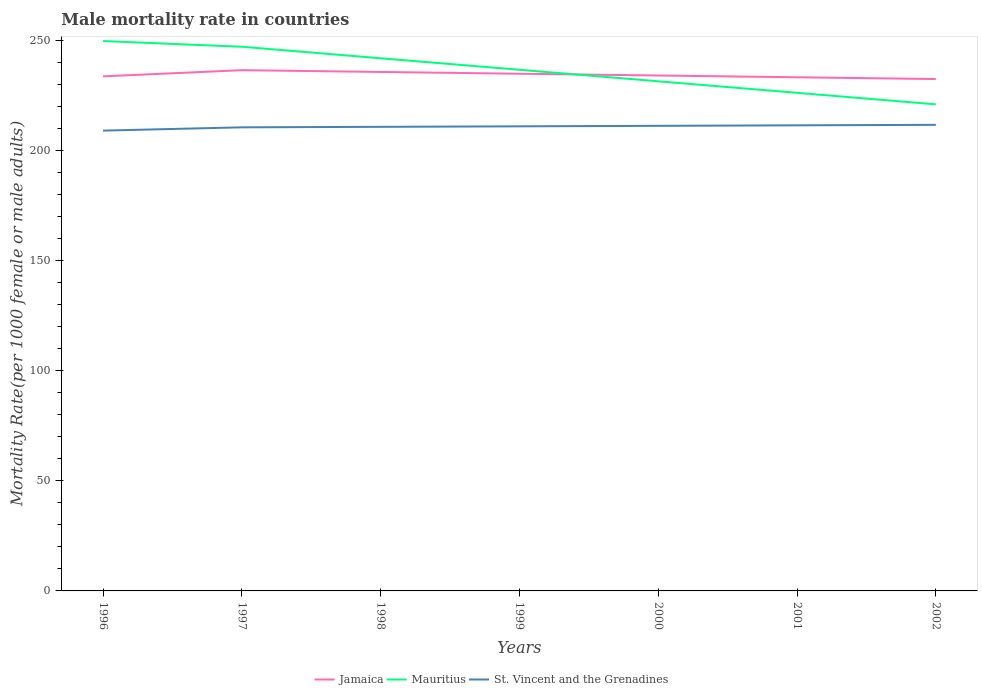How many different coloured lines are there?
Make the answer very short. 3. Is the number of lines equal to the number of legend labels?
Ensure brevity in your answer.  Yes. Across all years, what is the maximum male mortality rate in Jamaica?
Provide a short and direct response. 232.63. In which year was the male mortality rate in Jamaica maximum?
Give a very brief answer. 2002. What is the total male mortality rate in St. Vincent and the Grenadines in the graph?
Give a very brief answer. -1.72. What is the difference between the highest and the second highest male mortality rate in Jamaica?
Your answer should be very brief. 4.03. Is the male mortality rate in St. Vincent and the Grenadines strictly greater than the male mortality rate in Jamaica over the years?
Your answer should be compact. Yes. How many lines are there?
Offer a terse response. 3. How many years are there in the graph?
Give a very brief answer. 7. What is the title of the graph?
Make the answer very short. Male mortality rate in countries. Does "Central African Republic" appear as one of the legend labels in the graph?
Make the answer very short. No. What is the label or title of the X-axis?
Ensure brevity in your answer.  Years. What is the label or title of the Y-axis?
Your answer should be very brief. Mortality Rate(per 1000 female or male adults). What is the Mortality Rate(per 1000 female or male adults) in Jamaica in 1996?
Your answer should be compact. 233.86. What is the Mortality Rate(per 1000 female or male adults) in Mauritius in 1996?
Offer a very short reply. 249.9. What is the Mortality Rate(per 1000 female or male adults) of St. Vincent and the Grenadines in 1996?
Your answer should be compact. 209.2. What is the Mortality Rate(per 1000 female or male adults) of Jamaica in 1997?
Your response must be concise. 236.67. What is the Mortality Rate(per 1000 female or male adults) in Mauritius in 1997?
Your answer should be compact. 247.32. What is the Mortality Rate(per 1000 female or male adults) of St. Vincent and the Grenadines in 1997?
Ensure brevity in your answer.  210.69. What is the Mortality Rate(per 1000 female or male adults) of Jamaica in 1998?
Offer a very short reply. 235.86. What is the Mortality Rate(per 1000 female or male adults) of Mauritius in 1998?
Your response must be concise. 242.08. What is the Mortality Rate(per 1000 female or male adults) in St. Vincent and the Grenadines in 1998?
Offer a very short reply. 210.92. What is the Mortality Rate(per 1000 female or male adults) of Jamaica in 1999?
Provide a succinct answer. 235.05. What is the Mortality Rate(per 1000 female or male adults) of Mauritius in 1999?
Your answer should be very brief. 236.85. What is the Mortality Rate(per 1000 female or male adults) in St. Vincent and the Grenadines in 1999?
Provide a succinct answer. 211.15. What is the Mortality Rate(per 1000 female or male adults) of Jamaica in 2000?
Your response must be concise. 234.25. What is the Mortality Rate(per 1000 female or male adults) in Mauritius in 2000?
Provide a short and direct response. 231.61. What is the Mortality Rate(per 1000 female or male adults) in St. Vincent and the Grenadines in 2000?
Offer a terse response. 211.38. What is the Mortality Rate(per 1000 female or male adults) of Jamaica in 2001?
Offer a terse response. 233.44. What is the Mortality Rate(per 1000 female or male adults) of Mauritius in 2001?
Make the answer very short. 226.38. What is the Mortality Rate(per 1000 female or male adults) of St. Vincent and the Grenadines in 2001?
Give a very brief answer. 211.6. What is the Mortality Rate(per 1000 female or male adults) in Jamaica in 2002?
Give a very brief answer. 232.63. What is the Mortality Rate(per 1000 female or male adults) in Mauritius in 2002?
Provide a succinct answer. 221.14. What is the Mortality Rate(per 1000 female or male adults) in St. Vincent and the Grenadines in 2002?
Give a very brief answer. 211.83. Across all years, what is the maximum Mortality Rate(per 1000 female or male adults) in Jamaica?
Ensure brevity in your answer.  236.67. Across all years, what is the maximum Mortality Rate(per 1000 female or male adults) of Mauritius?
Keep it short and to the point. 249.9. Across all years, what is the maximum Mortality Rate(per 1000 female or male adults) in St. Vincent and the Grenadines?
Your answer should be compact. 211.83. Across all years, what is the minimum Mortality Rate(per 1000 female or male adults) of Jamaica?
Your answer should be compact. 232.63. Across all years, what is the minimum Mortality Rate(per 1000 female or male adults) of Mauritius?
Keep it short and to the point. 221.14. Across all years, what is the minimum Mortality Rate(per 1000 female or male adults) in St. Vincent and the Grenadines?
Offer a terse response. 209.2. What is the total Mortality Rate(per 1000 female or male adults) in Jamaica in the graph?
Provide a short and direct response. 1641.76. What is the total Mortality Rate(per 1000 female or male adults) in Mauritius in the graph?
Your response must be concise. 1655.28. What is the total Mortality Rate(per 1000 female or male adults) in St. Vincent and the Grenadines in the graph?
Keep it short and to the point. 1476.77. What is the difference between the Mortality Rate(per 1000 female or male adults) of Jamaica in 1996 and that in 1997?
Your response must be concise. -2.81. What is the difference between the Mortality Rate(per 1000 female or male adults) of Mauritius in 1996 and that in 1997?
Keep it short and to the point. 2.59. What is the difference between the Mortality Rate(per 1000 female or male adults) in St. Vincent and the Grenadines in 1996 and that in 1997?
Provide a succinct answer. -1.5. What is the difference between the Mortality Rate(per 1000 female or male adults) of Jamaica in 1996 and that in 1998?
Your response must be concise. -2. What is the difference between the Mortality Rate(per 1000 female or male adults) of Mauritius in 1996 and that in 1998?
Provide a succinct answer. 7.82. What is the difference between the Mortality Rate(per 1000 female or male adults) in St. Vincent and the Grenadines in 1996 and that in 1998?
Provide a succinct answer. -1.72. What is the difference between the Mortality Rate(per 1000 female or male adults) of Jamaica in 1996 and that in 1999?
Provide a short and direct response. -1.2. What is the difference between the Mortality Rate(per 1000 female or male adults) of Mauritius in 1996 and that in 1999?
Your response must be concise. 13.06. What is the difference between the Mortality Rate(per 1000 female or male adults) of St. Vincent and the Grenadines in 1996 and that in 1999?
Your answer should be very brief. -1.95. What is the difference between the Mortality Rate(per 1000 female or male adults) in Jamaica in 1996 and that in 2000?
Offer a very short reply. -0.39. What is the difference between the Mortality Rate(per 1000 female or male adults) of Mauritius in 1996 and that in 2000?
Provide a short and direct response. 18.29. What is the difference between the Mortality Rate(per 1000 female or male adults) of St. Vincent and the Grenadines in 1996 and that in 2000?
Offer a very short reply. -2.18. What is the difference between the Mortality Rate(per 1000 female or male adults) in Jamaica in 1996 and that in 2001?
Your answer should be compact. 0.42. What is the difference between the Mortality Rate(per 1000 female or male adults) in Mauritius in 1996 and that in 2001?
Keep it short and to the point. 23.53. What is the difference between the Mortality Rate(per 1000 female or male adults) in St. Vincent and the Grenadines in 1996 and that in 2001?
Your answer should be very brief. -2.4. What is the difference between the Mortality Rate(per 1000 female or male adults) in Jamaica in 1996 and that in 2002?
Ensure brevity in your answer.  1.23. What is the difference between the Mortality Rate(per 1000 female or male adults) in Mauritius in 1996 and that in 2002?
Keep it short and to the point. 28.76. What is the difference between the Mortality Rate(per 1000 female or male adults) in St. Vincent and the Grenadines in 1996 and that in 2002?
Keep it short and to the point. -2.63. What is the difference between the Mortality Rate(per 1000 female or male adults) of Jamaica in 1997 and that in 1998?
Your answer should be very brief. 0.81. What is the difference between the Mortality Rate(per 1000 female or male adults) in Mauritius in 1997 and that in 1998?
Your answer should be very brief. 5.24. What is the difference between the Mortality Rate(per 1000 female or male adults) of St. Vincent and the Grenadines in 1997 and that in 1998?
Ensure brevity in your answer.  -0.23. What is the difference between the Mortality Rate(per 1000 female or male adults) of Jamaica in 1997 and that in 1999?
Offer a terse response. 1.61. What is the difference between the Mortality Rate(per 1000 female or male adults) in Mauritius in 1997 and that in 1999?
Your answer should be compact. 10.47. What is the difference between the Mortality Rate(per 1000 female or male adults) in St. Vincent and the Grenadines in 1997 and that in 1999?
Keep it short and to the point. -0.45. What is the difference between the Mortality Rate(per 1000 female or male adults) of Jamaica in 1997 and that in 2000?
Offer a very short reply. 2.42. What is the difference between the Mortality Rate(per 1000 female or male adults) in Mauritius in 1997 and that in 2000?
Ensure brevity in your answer.  15.71. What is the difference between the Mortality Rate(per 1000 female or male adults) of St. Vincent and the Grenadines in 1997 and that in 2000?
Offer a very short reply. -0.68. What is the difference between the Mortality Rate(per 1000 female or male adults) in Jamaica in 1997 and that in 2001?
Keep it short and to the point. 3.23. What is the difference between the Mortality Rate(per 1000 female or male adults) in Mauritius in 1997 and that in 2001?
Give a very brief answer. 20.94. What is the difference between the Mortality Rate(per 1000 female or male adults) in St. Vincent and the Grenadines in 1997 and that in 2001?
Your response must be concise. -0.91. What is the difference between the Mortality Rate(per 1000 female or male adults) in Jamaica in 1997 and that in 2002?
Offer a very short reply. 4.03. What is the difference between the Mortality Rate(per 1000 female or male adults) in Mauritius in 1997 and that in 2002?
Offer a very short reply. 26.18. What is the difference between the Mortality Rate(per 1000 female or male adults) of St. Vincent and the Grenadines in 1997 and that in 2002?
Provide a succinct answer. -1.14. What is the difference between the Mortality Rate(per 1000 female or male adults) of Jamaica in 1998 and that in 1999?
Offer a terse response. 0.81. What is the difference between the Mortality Rate(per 1000 female or male adults) of Mauritius in 1998 and that in 1999?
Give a very brief answer. 5.24. What is the difference between the Mortality Rate(per 1000 female or male adults) in St. Vincent and the Grenadines in 1998 and that in 1999?
Provide a succinct answer. -0.23. What is the difference between the Mortality Rate(per 1000 female or male adults) in Jamaica in 1998 and that in 2000?
Offer a very short reply. 1.61. What is the difference between the Mortality Rate(per 1000 female or male adults) of Mauritius in 1998 and that in 2000?
Your response must be concise. 10.47. What is the difference between the Mortality Rate(per 1000 female or male adults) in St. Vincent and the Grenadines in 1998 and that in 2000?
Make the answer very short. -0.45. What is the difference between the Mortality Rate(per 1000 female or male adults) in Jamaica in 1998 and that in 2001?
Make the answer very short. 2.42. What is the difference between the Mortality Rate(per 1000 female or male adults) of Mauritius in 1998 and that in 2001?
Provide a succinct answer. 15.71. What is the difference between the Mortality Rate(per 1000 female or male adults) of St. Vincent and the Grenadines in 1998 and that in 2001?
Ensure brevity in your answer.  -0.68. What is the difference between the Mortality Rate(per 1000 female or male adults) of Jamaica in 1998 and that in 2002?
Your answer should be compact. 3.23. What is the difference between the Mortality Rate(per 1000 female or male adults) of Mauritius in 1998 and that in 2002?
Give a very brief answer. 20.94. What is the difference between the Mortality Rate(per 1000 female or male adults) in St. Vincent and the Grenadines in 1998 and that in 2002?
Keep it short and to the point. -0.91. What is the difference between the Mortality Rate(per 1000 female or male adults) in Jamaica in 1999 and that in 2000?
Your answer should be compact. 0.81. What is the difference between the Mortality Rate(per 1000 female or male adults) of Mauritius in 1999 and that in 2000?
Your response must be concise. 5.24. What is the difference between the Mortality Rate(per 1000 female or male adults) of St. Vincent and the Grenadines in 1999 and that in 2000?
Provide a succinct answer. -0.23. What is the difference between the Mortality Rate(per 1000 female or male adults) in Jamaica in 1999 and that in 2001?
Provide a succinct answer. 1.61. What is the difference between the Mortality Rate(per 1000 female or male adults) of Mauritius in 1999 and that in 2001?
Your response must be concise. 10.47. What is the difference between the Mortality Rate(per 1000 female or male adults) of St. Vincent and the Grenadines in 1999 and that in 2001?
Provide a succinct answer. -0.45. What is the difference between the Mortality Rate(per 1000 female or male adults) of Jamaica in 1999 and that in 2002?
Provide a short and direct response. 2.42. What is the difference between the Mortality Rate(per 1000 female or male adults) of Mauritius in 1999 and that in 2002?
Keep it short and to the point. 15.71. What is the difference between the Mortality Rate(per 1000 female or male adults) of St. Vincent and the Grenadines in 1999 and that in 2002?
Offer a terse response. -0.68. What is the difference between the Mortality Rate(per 1000 female or male adults) of Jamaica in 2000 and that in 2001?
Provide a short and direct response. 0.81. What is the difference between the Mortality Rate(per 1000 female or male adults) in Mauritius in 2000 and that in 2001?
Offer a terse response. 5.24. What is the difference between the Mortality Rate(per 1000 female or male adults) in St. Vincent and the Grenadines in 2000 and that in 2001?
Your response must be concise. -0.23. What is the difference between the Mortality Rate(per 1000 female or male adults) of Jamaica in 2000 and that in 2002?
Your response must be concise. 1.61. What is the difference between the Mortality Rate(per 1000 female or male adults) of Mauritius in 2000 and that in 2002?
Your answer should be very brief. 10.47. What is the difference between the Mortality Rate(per 1000 female or male adults) of St. Vincent and the Grenadines in 2000 and that in 2002?
Ensure brevity in your answer.  -0.45. What is the difference between the Mortality Rate(per 1000 female or male adults) of Jamaica in 2001 and that in 2002?
Provide a succinct answer. 0.81. What is the difference between the Mortality Rate(per 1000 female or male adults) in Mauritius in 2001 and that in 2002?
Your answer should be compact. 5.24. What is the difference between the Mortality Rate(per 1000 female or male adults) of St. Vincent and the Grenadines in 2001 and that in 2002?
Your answer should be very brief. -0.23. What is the difference between the Mortality Rate(per 1000 female or male adults) in Jamaica in 1996 and the Mortality Rate(per 1000 female or male adults) in Mauritius in 1997?
Provide a succinct answer. -13.46. What is the difference between the Mortality Rate(per 1000 female or male adults) in Jamaica in 1996 and the Mortality Rate(per 1000 female or male adults) in St. Vincent and the Grenadines in 1997?
Offer a very short reply. 23.16. What is the difference between the Mortality Rate(per 1000 female or male adults) of Mauritius in 1996 and the Mortality Rate(per 1000 female or male adults) of St. Vincent and the Grenadines in 1997?
Offer a terse response. 39.21. What is the difference between the Mortality Rate(per 1000 female or male adults) of Jamaica in 1996 and the Mortality Rate(per 1000 female or male adults) of Mauritius in 1998?
Provide a succinct answer. -8.22. What is the difference between the Mortality Rate(per 1000 female or male adults) in Jamaica in 1996 and the Mortality Rate(per 1000 female or male adults) in St. Vincent and the Grenadines in 1998?
Offer a terse response. 22.94. What is the difference between the Mortality Rate(per 1000 female or male adults) in Mauritius in 1996 and the Mortality Rate(per 1000 female or male adults) in St. Vincent and the Grenadines in 1998?
Make the answer very short. 38.98. What is the difference between the Mortality Rate(per 1000 female or male adults) of Jamaica in 1996 and the Mortality Rate(per 1000 female or male adults) of Mauritius in 1999?
Your answer should be compact. -2.99. What is the difference between the Mortality Rate(per 1000 female or male adults) of Jamaica in 1996 and the Mortality Rate(per 1000 female or male adults) of St. Vincent and the Grenadines in 1999?
Ensure brevity in your answer.  22.71. What is the difference between the Mortality Rate(per 1000 female or male adults) in Mauritius in 1996 and the Mortality Rate(per 1000 female or male adults) in St. Vincent and the Grenadines in 1999?
Keep it short and to the point. 38.76. What is the difference between the Mortality Rate(per 1000 female or male adults) in Jamaica in 1996 and the Mortality Rate(per 1000 female or male adults) in Mauritius in 2000?
Provide a short and direct response. 2.25. What is the difference between the Mortality Rate(per 1000 female or male adults) in Jamaica in 1996 and the Mortality Rate(per 1000 female or male adults) in St. Vincent and the Grenadines in 2000?
Your answer should be compact. 22.48. What is the difference between the Mortality Rate(per 1000 female or male adults) in Mauritius in 1996 and the Mortality Rate(per 1000 female or male adults) in St. Vincent and the Grenadines in 2000?
Your answer should be compact. 38.53. What is the difference between the Mortality Rate(per 1000 female or male adults) of Jamaica in 1996 and the Mortality Rate(per 1000 female or male adults) of Mauritius in 2001?
Offer a terse response. 7.48. What is the difference between the Mortality Rate(per 1000 female or male adults) in Jamaica in 1996 and the Mortality Rate(per 1000 female or male adults) in St. Vincent and the Grenadines in 2001?
Offer a terse response. 22.26. What is the difference between the Mortality Rate(per 1000 female or male adults) of Mauritius in 1996 and the Mortality Rate(per 1000 female or male adults) of St. Vincent and the Grenadines in 2001?
Keep it short and to the point. 38.3. What is the difference between the Mortality Rate(per 1000 female or male adults) in Jamaica in 1996 and the Mortality Rate(per 1000 female or male adults) in Mauritius in 2002?
Give a very brief answer. 12.72. What is the difference between the Mortality Rate(per 1000 female or male adults) in Jamaica in 1996 and the Mortality Rate(per 1000 female or male adults) in St. Vincent and the Grenadines in 2002?
Make the answer very short. 22.03. What is the difference between the Mortality Rate(per 1000 female or male adults) in Mauritius in 1996 and the Mortality Rate(per 1000 female or male adults) in St. Vincent and the Grenadines in 2002?
Your answer should be compact. 38.07. What is the difference between the Mortality Rate(per 1000 female or male adults) of Jamaica in 1997 and the Mortality Rate(per 1000 female or male adults) of Mauritius in 1998?
Offer a terse response. -5.41. What is the difference between the Mortality Rate(per 1000 female or male adults) in Jamaica in 1997 and the Mortality Rate(per 1000 female or male adults) in St. Vincent and the Grenadines in 1998?
Offer a terse response. 25.75. What is the difference between the Mortality Rate(per 1000 female or male adults) in Mauritius in 1997 and the Mortality Rate(per 1000 female or male adults) in St. Vincent and the Grenadines in 1998?
Offer a terse response. 36.4. What is the difference between the Mortality Rate(per 1000 female or male adults) of Jamaica in 1997 and the Mortality Rate(per 1000 female or male adults) of Mauritius in 1999?
Give a very brief answer. -0.18. What is the difference between the Mortality Rate(per 1000 female or male adults) of Jamaica in 1997 and the Mortality Rate(per 1000 female or male adults) of St. Vincent and the Grenadines in 1999?
Make the answer very short. 25.52. What is the difference between the Mortality Rate(per 1000 female or male adults) in Mauritius in 1997 and the Mortality Rate(per 1000 female or male adults) in St. Vincent and the Grenadines in 1999?
Your response must be concise. 36.17. What is the difference between the Mortality Rate(per 1000 female or male adults) in Jamaica in 1997 and the Mortality Rate(per 1000 female or male adults) in Mauritius in 2000?
Your answer should be very brief. 5.06. What is the difference between the Mortality Rate(per 1000 female or male adults) in Jamaica in 1997 and the Mortality Rate(per 1000 female or male adults) in St. Vincent and the Grenadines in 2000?
Your answer should be very brief. 25.29. What is the difference between the Mortality Rate(per 1000 female or male adults) in Mauritius in 1997 and the Mortality Rate(per 1000 female or male adults) in St. Vincent and the Grenadines in 2000?
Keep it short and to the point. 35.94. What is the difference between the Mortality Rate(per 1000 female or male adults) of Jamaica in 1997 and the Mortality Rate(per 1000 female or male adults) of Mauritius in 2001?
Offer a very short reply. 10.29. What is the difference between the Mortality Rate(per 1000 female or male adults) of Jamaica in 1997 and the Mortality Rate(per 1000 female or male adults) of St. Vincent and the Grenadines in 2001?
Make the answer very short. 25.07. What is the difference between the Mortality Rate(per 1000 female or male adults) of Mauritius in 1997 and the Mortality Rate(per 1000 female or male adults) of St. Vincent and the Grenadines in 2001?
Offer a terse response. 35.72. What is the difference between the Mortality Rate(per 1000 female or male adults) of Jamaica in 1997 and the Mortality Rate(per 1000 female or male adults) of Mauritius in 2002?
Provide a short and direct response. 15.53. What is the difference between the Mortality Rate(per 1000 female or male adults) in Jamaica in 1997 and the Mortality Rate(per 1000 female or male adults) in St. Vincent and the Grenadines in 2002?
Your answer should be very brief. 24.84. What is the difference between the Mortality Rate(per 1000 female or male adults) in Mauritius in 1997 and the Mortality Rate(per 1000 female or male adults) in St. Vincent and the Grenadines in 2002?
Give a very brief answer. 35.49. What is the difference between the Mortality Rate(per 1000 female or male adults) of Jamaica in 1998 and the Mortality Rate(per 1000 female or male adults) of Mauritius in 1999?
Your response must be concise. -0.99. What is the difference between the Mortality Rate(per 1000 female or male adults) of Jamaica in 1998 and the Mortality Rate(per 1000 female or male adults) of St. Vincent and the Grenadines in 1999?
Offer a very short reply. 24.71. What is the difference between the Mortality Rate(per 1000 female or male adults) of Mauritius in 1998 and the Mortality Rate(per 1000 female or male adults) of St. Vincent and the Grenadines in 1999?
Your answer should be compact. 30.93. What is the difference between the Mortality Rate(per 1000 female or male adults) in Jamaica in 1998 and the Mortality Rate(per 1000 female or male adults) in Mauritius in 2000?
Make the answer very short. 4.25. What is the difference between the Mortality Rate(per 1000 female or male adults) in Jamaica in 1998 and the Mortality Rate(per 1000 female or male adults) in St. Vincent and the Grenadines in 2000?
Ensure brevity in your answer.  24.49. What is the difference between the Mortality Rate(per 1000 female or male adults) of Mauritius in 1998 and the Mortality Rate(per 1000 female or male adults) of St. Vincent and the Grenadines in 2000?
Your answer should be compact. 30.71. What is the difference between the Mortality Rate(per 1000 female or male adults) in Jamaica in 1998 and the Mortality Rate(per 1000 female or male adults) in Mauritius in 2001?
Make the answer very short. 9.48. What is the difference between the Mortality Rate(per 1000 female or male adults) of Jamaica in 1998 and the Mortality Rate(per 1000 female or male adults) of St. Vincent and the Grenadines in 2001?
Offer a very short reply. 24.26. What is the difference between the Mortality Rate(per 1000 female or male adults) in Mauritius in 1998 and the Mortality Rate(per 1000 female or male adults) in St. Vincent and the Grenadines in 2001?
Offer a very short reply. 30.48. What is the difference between the Mortality Rate(per 1000 female or male adults) of Jamaica in 1998 and the Mortality Rate(per 1000 female or male adults) of Mauritius in 2002?
Your answer should be compact. 14.72. What is the difference between the Mortality Rate(per 1000 female or male adults) in Jamaica in 1998 and the Mortality Rate(per 1000 female or male adults) in St. Vincent and the Grenadines in 2002?
Provide a succinct answer. 24.03. What is the difference between the Mortality Rate(per 1000 female or male adults) of Mauritius in 1998 and the Mortality Rate(per 1000 female or male adults) of St. Vincent and the Grenadines in 2002?
Your answer should be very brief. 30.25. What is the difference between the Mortality Rate(per 1000 female or male adults) in Jamaica in 1999 and the Mortality Rate(per 1000 female or male adults) in Mauritius in 2000?
Give a very brief answer. 3.44. What is the difference between the Mortality Rate(per 1000 female or male adults) in Jamaica in 1999 and the Mortality Rate(per 1000 female or male adults) in St. Vincent and the Grenadines in 2000?
Provide a succinct answer. 23.68. What is the difference between the Mortality Rate(per 1000 female or male adults) in Mauritius in 1999 and the Mortality Rate(per 1000 female or male adults) in St. Vincent and the Grenadines in 2000?
Provide a short and direct response. 25.47. What is the difference between the Mortality Rate(per 1000 female or male adults) in Jamaica in 1999 and the Mortality Rate(per 1000 female or male adults) in Mauritius in 2001?
Keep it short and to the point. 8.68. What is the difference between the Mortality Rate(per 1000 female or male adults) in Jamaica in 1999 and the Mortality Rate(per 1000 female or male adults) in St. Vincent and the Grenadines in 2001?
Your answer should be very brief. 23.45. What is the difference between the Mortality Rate(per 1000 female or male adults) in Mauritius in 1999 and the Mortality Rate(per 1000 female or male adults) in St. Vincent and the Grenadines in 2001?
Provide a short and direct response. 25.24. What is the difference between the Mortality Rate(per 1000 female or male adults) of Jamaica in 1999 and the Mortality Rate(per 1000 female or male adults) of Mauritius in 2002?
Keep it short and to the point. 13.91. What is the difference between the Mortality Rate(per 1000 female or male adults) of Jamaica in 1999 and the Mortality Rate(per 1000 female or male adults) of St. Vincent and the Grenadines in 2002?
Offer a terse response. 23.22. What is the difference between the Mortality Rate(per 1000 female or male adults) in Mauritius in 1999 and the Mortality Rate(per 1000 female or male adults) in St. Vincent and the Grenadines in 2002?
Your answer should be compact. 25.02. What is the difference between the Mortality Rate(per 1000 female or male adults) of Jamaica in 2000 and the Mortality Rate(per 1000 female or male adults) of Mauritius in 2001?
Give a very brief answer. 7.87. What is the difference between the Mortality Rate(per 1000 female or male adults) of Jamaica in 2000 and the Mortality Rate(per 1000 female or male adults) of St. Vincent and the Grenadines in 2001?
Offer a very short reply. 22.64. What is the difference between the Mortality Rate(per 1000 female or male adults) in Mauritius in 2000 and the Mortality Rate(per 1000 female or male adults) in St. Vincent and the Grenadines in 2001?
Your answer should be very brief. 20.01. What is the difference between the Mortality Rate(per 1000 female or male adults) in Jamaica in 2000 and the Mortality Rate(per 1000 female or male adults) in Mauritius in 2002?
Keep it short and to the point. 13.11. What is the difference between the Mortality Rate(per 1000 female or male adults) of Jamaica in 2000 and the Mortality Rate(per 1000 female or male adults) of St. Vincent and the Grenadines in 2002?
Offer a very short reply. 22.42. What is the difference between the Mortality Rate(per 1000 female or male adults) in Mauritius in 2000 and the Mortality Rate(per 1000 female or male adults) in St. Vincent and the Grenadines in 2002?
Provide a succinct answer. 19.78. What is the difference between the Mortality Rate(per 1000 female or male adults) of Jamaica in 2001 and the Mortality Rate(per 1000 female or male adults) of Mauritius in 2002?
Offer a terse response. 12.3. What is the difference between the Mortality Rate(per 1000 female or male adults) of Jamaica in 2001 and the Mortality Rate(per 1000 female or male adults) of St. Vincent and the Grenadines in 2002?
Your answer should be compact. 21.61. What is the difference between the Mortality Rate(per 1000 female or male adults) in Mauritius in 2001 and the Mortality Rate(per 1000 female or male adults) in St. Vincent and the Grenadines in 2002?
Your answer should be very brief. 14.55. What is the average Mortality Rate(per 1000 female or male adults) of Jamaica per year?
Ensure brevity in your answer.  234.54. What is the average Mortality Rate(per 1000 female or male adults) of Mauritius per year?
Give a very brief answer. 236.47. What is the average Mortality Rate(per 1000 female or male adults) in St. Vincent and the Grenadines per year?
Make the answer very short. 210.97. In the year 1996, what is the difference between the Mortality Rate(per 1000 female or male adults) in Jamaica and Mortality Rate(per 1000 female or male adults) in Mauritius?
Offer a terse response. -16.05. In the year 1996, what is the difference between the Mortality Rate(per 1000 female or male adults) of Jamaica and Mortality Rate(per 1000 female or male adults) of St. Vincent and the Grenadines?
Provide a short and direct response. 24.66. In the year 1996, what is the difference between the Mortality Rate(per 1000 female or male adults) in Mauritius and Mortality Rate(per 1000 female or male adults) in St. Vincent and the Grenadines?
Provide a short and direct response. 40.7. In the year 1997, what is the difference between the Mortality Rate(per 1000 female or male adults) of Jamaica and Mortality Rate(per 1000 female or male adults) of Mauritius?
Offer a terse response. -10.65. In the year 1997, what is the difference between the Mortality Rate(per 1000 female or male adults) of Jamaica and Mortality Rate(per 1000 female or male adults) of St. Vincent and the Grenadines?
Provide a succinct answer. 25.97. In the year 1997, what is the difference between the Mortality Rate(per 1000 female or male adults) of Mauritius and Mortality Rate(per 1000 female or male adults) of St. Vincent and the Grenadines?
Your response must be concise. 36.62. In the year 1998, what is the difference between the Mortality Rate(per 1000 female or male adults) in Jamaica and Mortality Rate(per 1000 female or male adults) in Mauritius?
Make the answer very short. -6.22. In the year 1998, what is the difference between the Mortality Rate(per 1000 female or male adults) in Jamaica and Mortality Rate(per 1000 female or male adults) in St. Vincent and the Grenadines?
Your response must be concise. 24.94. In the year 1998, what is the difference between the Mortality Rate(per 1000 female or male adults) of Mauritius and Mortality Rate(per 1000 female or male adults) of St. Vincent and the Grenadines?
Make the answer very short. 31.16. In the year 1999, what is the difference between the Mortality Rate(per 1000 female or male adults) of Jamaica and Mortality Rate(per 1000 female or male adults) of Mauritius?
Your response must be concise. -1.79. In the year 1999, what is the difference between the Mortality Rate(per 1000 female or male adults) in Jamaica and Mortality Rate(per 1000 female or male adults) in St. Vincent and the Grenadines?
Your answer should be compact. 23.91. In the year 1999, what is the difference between the Mortality Rate(per 1000 female or male adults) in Mauritius and Mortality Rate(per 1000 female or male adults) in St. Vincent and the Grenadines?
Offer a terse response. 25.7. In the year 2000, what is the difference between the Mortality Rate(per 1000 female or male adults) in Jamaica and Mortality Rate(per 1000 female or male adults) in Mauritius?
Your response must be concise. 2.64. In the year 2000, what is the difference between the Mortality Rate(per 1000 female or male adults) in Jamaica and Mortality Rate(per 1000 female or male adults) in St. Vincent and the Grenadines?
Keep it short and to the point. 22.87. In the year 2000, what is the difference between the Mortality Rate(per 1000 female or male adults) of Mauritius and Mortality Rate(per 1000 female or male adults) of St. Vincent and the Grenadines?
Make the answer very short. 20.24. In the year 2001, what is the difference between the Mortality Rate(per 1000 female or male adults) in Jamaica and Mortality Rate(per 1000 female or male adults) in Mauritius?
Offer a terse response. 7.06. In the year 2001, what is the difference between the Mortality Rate(per 1000 female or male adults) in Jamaica and Mortality Rate(per 1000 female or male adults) in St. Vincent and the Grenadines?
Keep it short and to the point. 21.84. In the year 2001, what is the difference between the Mortality Rate(per 1000 female or male adults) of Mauritius and Mortality Rate(per 1000 female or male adults) of St. Vincent and the Grenadines?
Make the answer very short. 14.77. In the year 2002, what is the difference between the Mortality Rate(per 1000 female or male adults) of Jamaica and Mortality Rate(per 1000 female or male adults) of Mauritius?
Offer a terse response. 11.49. In the year 2002, what is the difference between the Mortality Rate(per 1000 female or male adults) in Jamaica and Mortality Rate(per 1000 female or male adults) in St. Vincent and the Grenadines?
Your answer should be compact. 20.8. In the year 2002, what is the difference between the Mortality Rate(per 1000 female or male adults) in Mauritius and Mortality Rate(per 1000 female or male adults) in St. Vincent and the Grenadines?
Provide a short and direct response. 9.31. What is the ratio of the Mortality Rate(per 1000 female or male adults) of Jamaica in 1996 to that in 1997?
Keep it short and to the point. 0.99. What is the ratio of the Mortality Rate(per 1000 female or male adults) of Mauritius in 1996 to that in 1997?
Offer a very short reply. 1.01. What is the ratio of the Mortality Rate(per 1000 female or male adults) in St. Vincent and the Grenadines in 1996 to that in 1997?
Keep it short and to the point. 0.99. What is the ratio of the Mortality Rate(per 1000 female or male adults) of Jamaica in 1996 to that in 1998?
Make the answer very short. 0.99. What is the ratio of the Mortality Rate(per 1000 female or male adults) in Mauritius in 1996 to that in 1998?
Keep it short and to the point. 1.03. What is the ratio of the Mortality Rate(per 1000 female or male adults) in St. Vincent and the Grenadines in 1996 to that in 1998?
Make the answer very short. 0.99. What is the ratio of the Mortality Rate(per 1000 female or male adults) in Jamaica in 1996 to that in 1999?
Give a very brief answer. 0.99. What is the ratio of the Mortality Rate(per 1000 female or male adults) in Mauritius in 1996 to that in 1999?
Provide a succinct answer. 1.06. What is the ratio of the Mortality Rate(per 1000 female or male adults) of Jamaica in 1996 to that in 2000?
Provide a short and direct response. 1. What is the ratio of the Mortality Rate(per 1000 female or male adults) of Mauritius in 1996 to that in 2000?
Your answer should be compact. 1.08. What is the ratio of the Mortality Rate(per 1000 female or male adults) of Mauritius in 1996 to that in 2001?
Give a very brief answer. 1.1. What is the ratio of the Mortality Rate(per 1000 female or male adults) of St. Vincent and the Grenadines in 1996 to that in 2001?
Your answer should be compact. 0.99. What is the ratio of the Mortality Rate(per 1000 female or male adults) of Jamaica in 1996 to that in 2002?
Keep it short and to the point. 1.01. What is the ratio of the Mortality Rate(per 1000 female or male adults) of Mauritius in 1996 to that in 2002?
Ensure brevity in your answer.  1.13. What is the ratio of the Mortality Rate(per 1000 female or male adults) in St. Vincent and the Grenadines in 1996 to that in 2002?
Your answer should be compact. 0.99. What is the ratio of the Mortality Rate(per 1000 female or male adults) in Jamaica in 1997 to that in 1998?
Provide a short and direct response. 1. What is the ratio of the Mortality Rate(per 1000 female or male adults) of Mauritius in 1997 to that in 1998?
Offer a very short reply. 1.02. What is the ratio of the Mortality Rate(per 1000 female or male adults) of St. Vincent and the Grenadines in 1997 to that in 1998?
Ensure brevity in your answer.  1. What is the ratio of the Mortality Rate(per 1000 female or male adults) of Mauritius in 1997 to that in 1999?
Make the answer very short. 1.04. What is the ratio of the Mortality Rate(per 1000 female or male adults) of St. Vincent and the Grenadines in 1997 to that in 1999?
Offer a terse response. 1. What is the ratio of the Mortality Rate(per 1000 female or male adults) in Jamaica in 1997 to that in 2000?
Your response must be concise. 1.01. What is the ratio of the Mortality Rate(per 1000 female or male adults) of Mauritius in 1997 to that in 2000?
Provide a succinct answer. 1.07. What is the ratio of the Mortality Rate(per 1000 female or male adults) in Jamaica in 1997 to that in 2001?
Offer a very short reply. 1.01. What is the ratio of the Mortality Rate(per 1000 female or male adults) of Mauritius in 1997 to that in 2001?
Your answer should be very brief. 1.09. What is the ratio of the Mortality Rate(per 1000 female or male adults) in Jamaica in 1997 to that in 2002?
Your answer should be compact. 1.02. What is the ratio of the Mortality Rate(per 1000 female or male adults) of Mauritius in 1997 to that in 2002?
Provide a succinct answer. 1.12. What is the ratio of the Mortality Rate(per 1000 female or male adults) in St. Vincent and the Grenadines in 1997 to that in 2002?
Keep it short and to the point. 0.99. What is the ratio of the Mortality Rate(per 1000 female or male adults) of Jamaica in 1998 to that in 1999?
Make the answer very short. 1. What is the ratio of the Mortality Rate(per 1000 female or male adults) in Mauritius in 1998 to that in 1999?
Ensure brevity in your answer.  1.02. What is the ratio of the Mortality Rate(per 1000 female or male adults) of Jamaica in 1998 to that in 2000?
Your answer should be very brief. 1.01. What is the ratio of the Mortality Rate(per 1000 female or male adults) of Mauritius in 1998 to that in 2000?
Keep it short and to the point. 1.05. What is the ratio of the Mortality Rate(per 1000 female or male adults) of Jamaica in 1998 to that in 2001?
Keep it short and to the point. 1.01. What is the ratio of the Mortality Rate(per 1000 female or male adults) in Mauritius in 1998 to that in 2001?
Make the answer very short. 1.07. What is the ratio of the Mortality Rate(per 1000 female or male adults) of Jamaica in 1998 to that in 2002?
Offer a very short reply. 1.01. What is the ratio of the Mortality Rate(per 1000 female or male adults) in Mauritius in 1998 to that in 2002?
Give a very brief answer. 1.09. What is the ratio of the Mortality Rate(per 1000 female or male adults) of St. Vincent and the Grenadines in 1998 to that in 2002?
Your answer should be compact. 1. What is the ratio of the Mortality Rate(per 1000 female or male adults) of Jamaica in 1999 to that in 2000?
Give a very brief answer. 1. What is the ratio of the Mortality Rate(per 1000 female or male adults) in Mauritius in 1999 to that in 2000?
Your answer should be compact. 1.02. What is the ratio of the Mortality Rate(per 1000 female or male adults) in Jamaica in 1999 to that in 2001?
Provide a succinct answer. 1.01. What is the ratio of the Mortality Rate(per 1000 female or male adults) of Mauritius in 1999 to that in 2001?
Ensure brevity in your answer.  1.05. What is the ratio of the Mortality Rate(per 1000 female or male adults) in St. Vincent and the Grenadines in 1999 to that in 2001?
Offer a very short reply. 1. What is the ratio of the Mortality Rate(per 1000 female or male adults) of Jamaica in 1999 to that in 2002?
Keep it short and to the point. 1.01. What is the ratio of the Mortality Rate(per 1000 female or male adults) of Mauritius in 1999 to that in 2002?
Offer a very short reply. 1.07. What is the ratio of the Mortality Rate(per 1000 female or male adults) of Jamaica in 2000 to that in 2001?
Ensure brevity in your answer.  1. What is the ratio of the Mortality Rate(per 1000 female or male adults) in Mauritius in 2000 to that in 2001?
Make the answer very short. 1.02. What is the ratio of the Mortality Rate(per 1000 female or male adults) in Jamaica in 2000 to that in 2002?
Provide a succinct answer. 1.01. What is the ratio of the Mortality Rate(per 1000 female or male adults) of Mauritius in 2000 to that in 2002?
Make the answer very short. 1.05. What is the ratio of the Mortality Rate(per 1000 female or male adults) in Jamaica in 2001 to that in 2002?
Your answer should be compact. 1. What is the ratio of the Mortality Rate(per 1000 female or male adults) of Mauritius in 2001 to that in 2002?
Offer a terse response. 1.02. What is the ratio of the Mortality Rate(per 1000 female or male adults) of St. Vincent and the Grenadines in 2001 to that in 2002?
Your answer should be very brief. 1. What is the difference between the highest and the second highest Mortality Rate(per 1000 female or male adults) in Jamaica?
Offer a terse response. 0.81. What is the difference between the highest and the second highest Mortality Rate(per 1000 female or male adults) in Mauritius?
Make the answer very short. 2.59. What is the difference between the highest and the second highest Mortality Rate(per 1000 female or male adults) in St. Vincent and the Grenadines?
Provide a short and direct response. 0.23. What is the difference between the highest and the lowest Mortality Rate(per 1000 female or male adults) of Jamaica?
Provide a succinct answer. 4.03. What is the difference between the highest and the lowest Mortality Rate(per 1000 female or male adults) of Mauritius?
Your answer should be compact. 28.76. What is the difference between the highest and the lowest Mortality Rate(per 1000 female or male adults) in St. Vincent and the Grenadines?
Offer a very short reply. 2.63. 